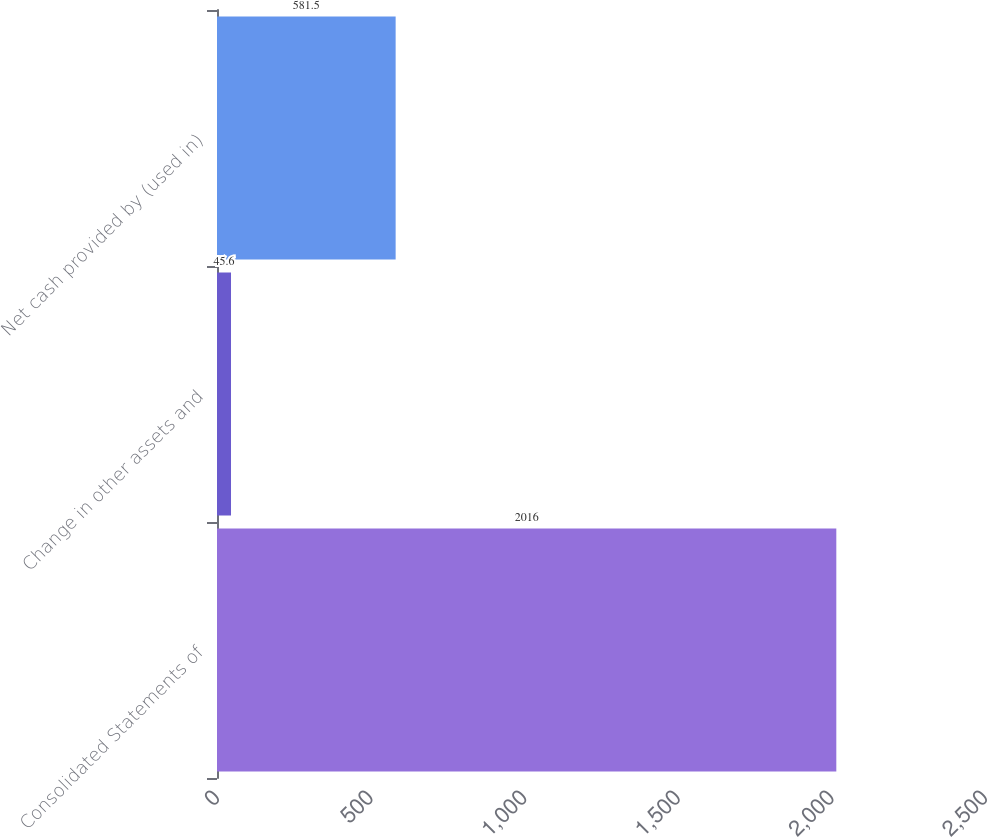Convert chart. <chart><loc_0><loc_0><loc_500><loc_500><bar_chart><fcel>Consolidated Statements of<fcel>Change in other assets and<fcel>Net cash provided by (used in)<nl><fcel>2016<fcel>45.6<fcel>581.5<nl></chart> 